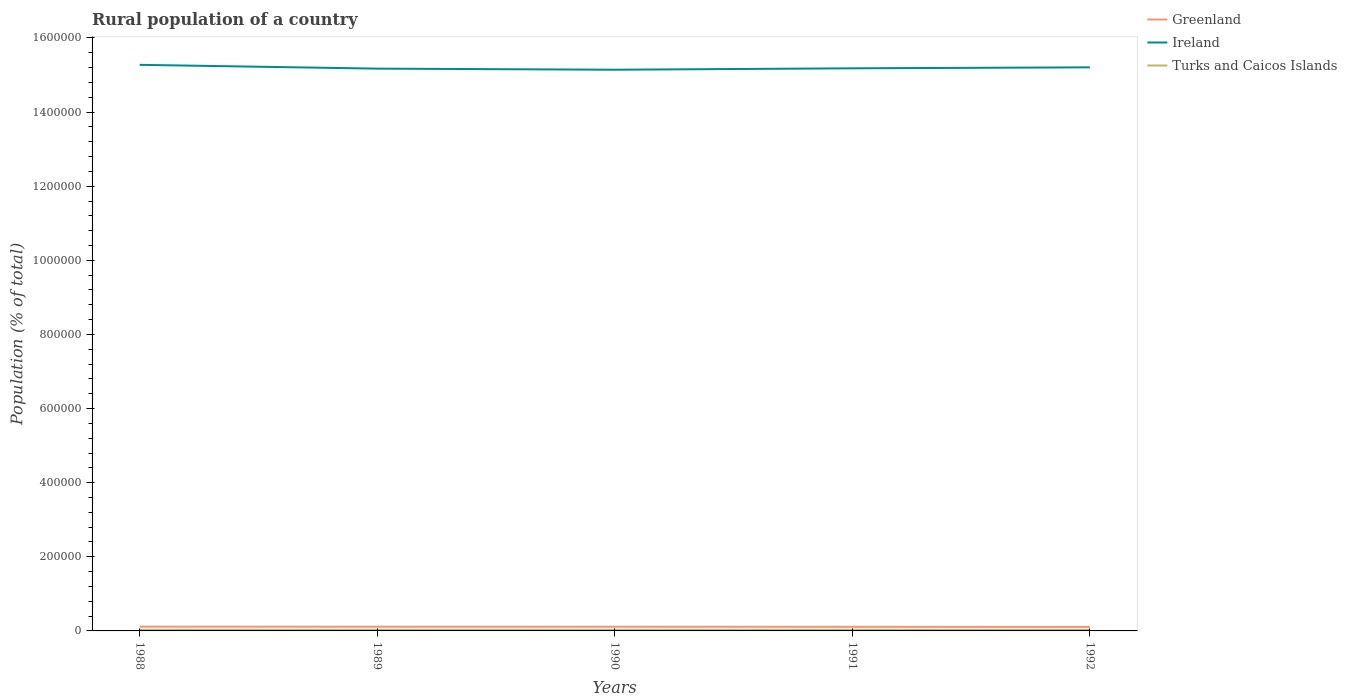How many different coloured lines are there?
Your response must be concise. 3. Does the line corresponding to Ireland intersect with the line corresponding to Turks and Caicos Islands?
Provide a succinct answer. No. Is the number of lines equal to the number of legend labels?
Your response must be concise. Yes. Across all years, what is the maximum rural population in Turks and Caicos Islands?
Make the answer very short. 2963. In which year was the rural population in Turks and Caicos Islands maximum?
Your answer should be very brief. 1990. What is the total rural population in Greenland in the graph?
Offer a very short reply. 605. What is the difference between the highest and the second highest rural population in Greenland?
Ensure brevity in your answer.  605. Does the graph contain any zero values?
Your answer should be compact. No. Does the graph contain grids?
Your response must be concise. No. How many legend labels are there?
Make the answer very short. 3. How are the legend labels stacked?
Your response must be concise. Vertical. What is the title of the graph?
Your answer should be very brief. Rural population of a country. What is the label or title of the Y-axis?
Your answer should be compact. Population (% of total). What is the Population (% of total) of Greenland in 1988?
Provide a short and direct response. 1.15e+04. What is the Population (% of total) in Ireland in 1988?
Keep it short and to the point. 1.53e+06. What is the Population (% of total) in Turks and Caicos Islands in 1988?
Offer a terse response. 3072. What is the Population (% of total) of Greenland in 1989?
Offer a very short reply. 1.14e+04. What is the Population (% of total) in Ireland in 1989?
Your response must be concise. 1.52e+06. What is the Population (% of total) in Turks and Caicos Islands in 1989?
Provide a succinct answer. 3006. What is the Population (% of total) of Greenland in 1990?
Your response must be concise. 1.13e+04. What is the Population (% of total) of Ireland in 1990?
Keep it short and to the point. 1.51e+06. What is the Population (% of total) in Turks and Caicos Islands in 1990?
Provide a succinct answer. 2963. What is the Population (% of total) of Greenland in 1991?
Your answer should be compact. 1.11e+04. What is the Population (% of total) in Ireland in 1991?
Keep it short and to the point. 1.52e+06. What is the Population (% of total) in Turks and Caicos Islands in 1991?
Give a very brief answer. 2986. What is the Population (% of total) in Greenland in 1992?
Offer a terse response. 1.09e+04. What is the Population (% of total) in Ireland in 1992?
Give a very brief answer. 1.52e+06. What is the Population (% of total) in Turks and Caicos Islands in 1992?
Provide a short and direct response. 3023. Across all years, what is the maximum Population (% of total) of Greenland?
Give a very brief answer. 1.15e+04. Across all years, what is the maximum Population (% of total) of Ireland?
Make the answer very short. 1.53e+06. Across all years, what is the maximum Population (% of total) of Turks and Caicos Islands?
Offer a terse response. 3072. Across all years, what is the minimum Population (% of total) of Greenland?
Your answer should be compact. 1.09e+04. Across all years, what is the minimum Population (% of total) of Ireland?
Your answer should be very brief. 1.51e+06. Across all years, what is the minimum Population (% of total) of Turks and Caicos Islands?
Ensure brevity in your answer.  2963. What is the total Population (% of total) in Greenland in the graph?
Your response must be concise. 5.62e+04. What is the total Population (% of total) in Ireland in the graph?
Ensure brevity in your answer.  7.60e+06. What is the total Population (% of total) in Turks and Caicos Islands in the graph?
Give a very brief answer. 1.50e+04. What is the difference between the Population (% of total) in Ireland in 1988 and that in 1989?
Give a very brief answer. 1.03e+04. What is the difference between the Population (% of total) in Turks and Caicos Islands in 1988 and that in 1989?
Give a very brief answer. 66. What is the difference between the Population (% of total) of Greenland in 1988 and that in 1990?
Offer a very short reply. 211. What is the difference between the Population (% of total) of Ireland in 1988 and that in 1990?
Your answer should be very brief. 1.32e+04. What is the difference between the Population (% of total) of Turks and Caicos Islands in 1988 and that in 1990?
Offer a very short reply. 109. What is the difference between the Population (% of total) of Greenland in 1988 and that in 1991?
Provide a short and direct response. 417. What is the difference between the Population (% of total) of Ireland in 1988 and that in 1991?
Offer a terse response. 9406. What is the difference between the Population (% of total) in Turks and Caicos Islands in 1988 and that in 1991?
Your answer should be very brief. 86. What is the difference between the Population (% of total) of Greenland in 1988 and that in 1992?
Your answer should be compact. 605. What is the difference between the Population (% of total) of Ireland in 1988 and that in 1992?
Offer a terse response. 6806. What is the difference between the Population (% of total) in Greenland in 1989 and that in 1990?
Offer a terse response. 126. What is the difference between the Population (% of total) in Ireland in 1989 and that in 1990?
Provide a short and direct response. 2935. What is the difference between the Population (% of total) in Turks and Caicos Islands in 1989 and that in 1990?
Your response must be concise. 43. What is the difference between the Population (% of total) of Greenland in 1989 and that in 1991?
Keep it short and to the point. 332. What is the difference between the Population (% of total) in Ireland in 1989 and that in 1991?
Provide a short and direct response. -848. What is the difference between the Population (% of total) of Greenland in 1989 and that in 1992?
Offer a terse response. 520. What is the difference between the Population (% of total) of Ireland in 1989 and that in 1992?
Offer a very short reply. -3448. What is the difference between the Population (% of total) in Greenland in 1990 and that in 1991?
Make the answer very short. 206. What is the difference between the Population (% of total) in Ireland in 1990 and that in 1991?
Make the answer very short. -3783. What is the difference between the Population (% of total) in Greenland in 1990 and that in 1992?
Offer a very short reply. 394. What is the difference between the Population (% of total) of Ireland in 1990 and that in 1992?
Offer a terse response. -6383. What is the difference between the Population (% of total) in Turks and Caicos Islands in 1990 and that in 1992?
Provide a succinct answer. -60. What is the difference between the Population (% of total) of Greenland in 1991 and that in 1992?
Make the answer very short. 188. What is the difference between the Population (% of total) of Ireland in 1991 and that in 1992?
Offer a terse response. -2600. What is the difference between the Population (% of total) in Turks and Caicos Islands in 1991 and that in 1992?
Offer a terse response. -37. What is the difference between the Population (% of total) in Greenland in 1988 and the Population (% of total) in Ireland in 1989?
Give a very brief answer. -1.51e+06. What is the difference between the Population (% of total) in Greenland in 1988 and the Population (% of total) in Turks and Caicos Islands in 1989?
Provide a short and direct response. 8493. What is the difference between the Population (% of total) of Ireland in 1988 and the Population (% of total) of Turks and Caicos Islands in 1989?
Your answer should be compact. 1.52e+06. What is the difference between the Population (% of total) of Greenland in 1988 and the Population (% of total) of Ireland in 1990?
Your response must be concise. -1.50e+06. What is the difference between the Population (% of total) in Greenland in 1988 and the Population (% of total) in Turks and Caicos Islands in 1990?
Your answer should be compact. 8536. What is the difference between the Population (% of total) in Ireland in 1988 and the Population (% of total) in Turks and Caicos Islands in 1990?
Provide a short and direct response. 1.52e+06. What is the difference between the Population (% of total) in Greenland in 1988 and the Population (% of total) in Ireland in 1991?
Provide a succinct answer. -1.51e+06. What is the difference between the Population (% of total) in Greenland in 1988 and the Population (% of total) in Turks and Caicos Islands in 1991?
Provide a short and direct response. 8513. What is the difference between the Population (% of total) in Ireland in 1988 and the Population (% of total) in Turks and Caicos Islands in 1991?
Provide a succinct answer. 1.52e+06. What is the difference between the Population (% of total) in Greenland in 1988 and the Population (% of total) in Ireland in 1992?
Offer a very short reply. -1.51e+06. What is the difference between the Population (% of total) of Greenland in 1988 and the Population (% of total) of Turks and Caicos Islands in 1992?
Keep it short and to the point. 8476. What is the difference between the Population (% of total) in Ireland in 1988 and the Population (% of total) in Turks and Caicos Islands in 1992?
Provide a succinct answer. 1.52e+06. What is the difference between the Population (% of total) in Greenland in 1989 and the Population (% of total) in Ireland in 1990?
Provide a succinct answer. -1.50e+06. What is the difference between the Population (% of total) of Greenland in 1989 and the Population (% of total) of Turks and Caicos Islands in 1990?
Your response must be concise. 8451. What is the difference between the Population (% of total) in Ireland in 1989 and the Population (% of total) in Turks and Caicos Islands in 1990?
Your answer should be very brief. 1.51e+06. What is the difference between the Population (% of total) of Greenland in 1989 and the Population (% of total) of Ireland in 1991?
Make the answer very short. -1.51e+06. What is the difference between the Population (% of total) of Greenland in 1989 and the Population (% of total) of Turks and Caicos Islands in 1991?
Offer a very short reply. 8428. What is the difference between the Population (% of total) in Ireland in 1989 and the Population (% of total) in Turks and Caicos Islands in 1991?
Your response must be concise. 1.51e+06. What is the difference between the Population (% of total) of Greenland in 1989 and the Population (% of total) of Ireland in 1992?
Your response must be concise. -1.51e+06. What is the difference between the Population (% of total) of Greenland in 1989 and the Population (% of total) of Turks and Caicos Islands in 1992?
Ensure brevity in your answer.  8391. What is the difference between the Population (% of total) in Ireland in 1989 and the Population (% of total) in Turks and Caicos Islands in 1992?
Provide a succinct answer. 1.51e+06. What is the difference between the Population (% of total) in Greenland in 1990 and the Population (% of total) in Ireland in 1991?
Your answer should be compact. -1.51e+06. What is the difference between the Population (% of total) of Greenland in 1990 and the Population (% of total) of Turks and Caicos Islands in 1991?
Ensure brevity in your answer.  8302. What is the difference between the Population (% of total) of Ireland in 1990 and the Population (% of total) of Turks and Caicos Islands in 1991?
Give a very brief answer. 1.51e+06. What is the difference between the Population (% of total) of Greenland in 1990 and the Population (% of total) of Ireland in 1992?
Give a very brief answer. -1.51e+06. What is the difference between the Population (% of total) of Greenland in 1990 and the Population (% of total) of Turks and Caicos Islands in 1992?
Offer a very short reply. 8265. What is the difference between the Population (% of total) in Ireland in 1990 and the Population (% of total) in Turks and Caicos Islands in 1992?
Ensure brevity in your answer.  1.51e+06. What is the difference between the Population (% of total) in Greenland in 1991 and the Population (% of total) in Ireland in 1992?
Offer a very short reply. -1.51e+06. What is the difference between the Population (% of total) in Greenland in 1991 and the Population (% of total) in Turks and Caicos Islands in 1992?
Your response must be concise. 8059. What is the difference between the Population (% of total) in Ireland in 1991 and the Population (% of total) in Turks and Caicos Islands in 1992?
Offer a terse response. 1.52e+06. What is the average Population (% of total) in Greenland per year?
Your answer should be very brief. 1.12e+04. What is the average Population (% of total) of Ireland per year?
Your answer should be very brief. 1.52e+06. What is the average Population (% of total) in Turks and Caicos Islands per year?
Give a very brief answer. 3010. In the year 1988, what is the difference between the Population (% of total) in Greenland and Population (% of total) in Ireland?
Provide a short and direct response. -1.52e+06. In the year 1988, what is the difference between the Population (% of total) of Greenland and Population (% of total) of Turks and Caicos Islands?
Offer a terse response. 8427. In the year 1988, what is the difference between the Population (% of total) in Ireland and Population (% of total) in Turks and Caicos Islands?
Offer a terse response. 1.52e+06. In the year 1989, what is the difference between the Population (% of total) in Greenland and Population (% of total) in Ireland?
Your answer should be compact. -1.51e+06. In the year 1989, what is the difference between the Population (% of total) of Greenland and Population (% of total) of Turks and Caicos Islands?
Your response must be concise. 8408. In the year 1989, what is the difference between the Population (% of total) in Ireland and Population (% of total) in Turks and Caicos Islands?
Keep it short and to the point. 1.51e+06. In the year 1990, what is the difference between the Population (% of total) in Greenland and Population (% of total) in Ireland?
Your answer should be compact. -1.50e+06. In the year 1990, what is the difference between the Population (% of total) of Greenland and Population (% of total) of Turks and Caicos Islands?
Your answer should be compact. 8325. In the year 1990, what is the difference between the Population (% of total) in Ireland and Population (% of total) in Turks and Caicos Islands?
Offer a very short reply. 1.51e+06. In the year 1991, what is the difference between the Population (% of total) of Greenland and Population (% of total) of Ireland?
Make the answer very short. -1.51e+06. In the year 1991, what is the difference between the Population (% of total) of Greenland and Population (% of total) of Turks and Caicos Islands?
Offer a terse response. 8096. In the year 1991, what is the difference between the Population (% of total) of Ireland and Population (% of total) of Turks and Caicos Islands?
Give a very brief answer. 1.52e+06. In the year 1992, what is the difference between the Population (% of total) in Greenland and Population (% of total) in Ireland?
Make the answer very short. -1.51e+06. In the year 1992, what is the difference between the Population (% of total) of Greenland and Population (% of total) of Turks and Caicos Islands?
Give a very brief answer. 7871. In the year 1992, what is the difference between the Population (% of total) of Ireland and Population (% of total) of Turks and Caicos Islands?
Give a very brief answer. 1.52e+06. What is the ratio of the Population (% of total) of Greenland in 1988 to that in 1989?
Keep it short and to the point. 1.01. What is the ratio of the Population (% of total) in Ireland in 1988 to that in 1989?
Offer a terse response. 1.01. What is the ratio of the Population (% of total) of Turks and Caicos Islands in 1988 to that in 1989?
Provide a succinct answer. 1.02. What is the ratio of the Population (% of total) in Greenland in 1988 to that in 1990?
Provide a short and direct response. 1.02. What is the ratio of the Population (% of total) in Ireland in 1988 to that in 1990?
Ensure brevity in your answer.  1.01. What is the ratio of the Population (% of total) of Turks and Caicos Islands in 1988 to that in 1990?
Offer a very short reply. 1.04. What is the ratio of the Population (% of total) in Greenland in 1988 to that in 1991?
Offer a very short reply. 1.04. What is the ratio of the Population (% of total) of Ireland in 1988 to that in 1991?
Your answer should be very brief. 1.01. What is the ratio of the Population (% of total) in Turks and Caicos Islands in 1988 to that in 1991?
Give a very brief answer. 1.03. What is the ratio of the Population (% of total) in Greenland in 1988 to that in 1992?
Keep it short and to the point. 1.06. What is the ratio of the Population (% of total) of Turks and Caicos Islands in 1988 to that in 1992?
Your response must be concise. 1.02. What is the ratio of the Population (% of total) of Greenland in 1989 to that in 1990?
Offer a terse response. 1.01. What is the ratio of the Population (% of total) in Ireland in 1989 to that in 1990?
Make the answer very short. 1. What is the ratio of the Population (% of total) of Turks and Caicos Islands in 1989 to that in 1990?
Provide a short and direct response. 1.01. What is the ratio of the Population (% of total) in Turks and Caicos Islands in 1989 to that in 1991?
Make the answer very short. 1.01. What is the ratio of the Population (% of total) of Greenland in 1989 to that in 1992?
Give a very brief answer. 1.05. What is the ratio of the Population (% of total) of Ireland in 1989 to that in 1992?
Offer a terse response. 1. What is the ratio of the Population (% of total) in Greenland in 1990 to that in 1991?
Give a very brief answer. 1.02. What is the ratio of the Population (% of total) of Ireland in 1990 to that in 1991?
Your answer should be very brief. 1. What is the ratio of the Population (% of total) in Turks and Caicos Islands in 1990 to that in 1991?
Provide a short and direct response. 0.99. What is the ratio of the Population (% of total) in Greenland in 1990 to that in 1992?
Make the answer very short. 1.04. What is the ratio of the Population (% of total) of Turks and Caicos Islands in 1990 to that in 1992?
Your answer should be compact. 0.98. What is the ratio of the Population (% of total) of Greenland in 1991 to that in 1992?
Make the answer very short. 1.02. What is the difference between the highest and the second highest Population (% of total) in Greenland?
Make the answer very short. 85. What is the difference between the highest and the second highest Population (% of total) of Ireland?
Ensure brevity in your answer.  6806. What is the difference between the highest and the lowest Population (% of total) of Greenland?
Offer a very short reply. 605. What is the difference between the highest and the lowest Population (% of total) of Ireland?
Provide a short and direct response. 1.32e+04. What is the difference between the highest and the lowest Population (% of total) in Turks and Caicos Islands?
Your answer should be compact. 109. 